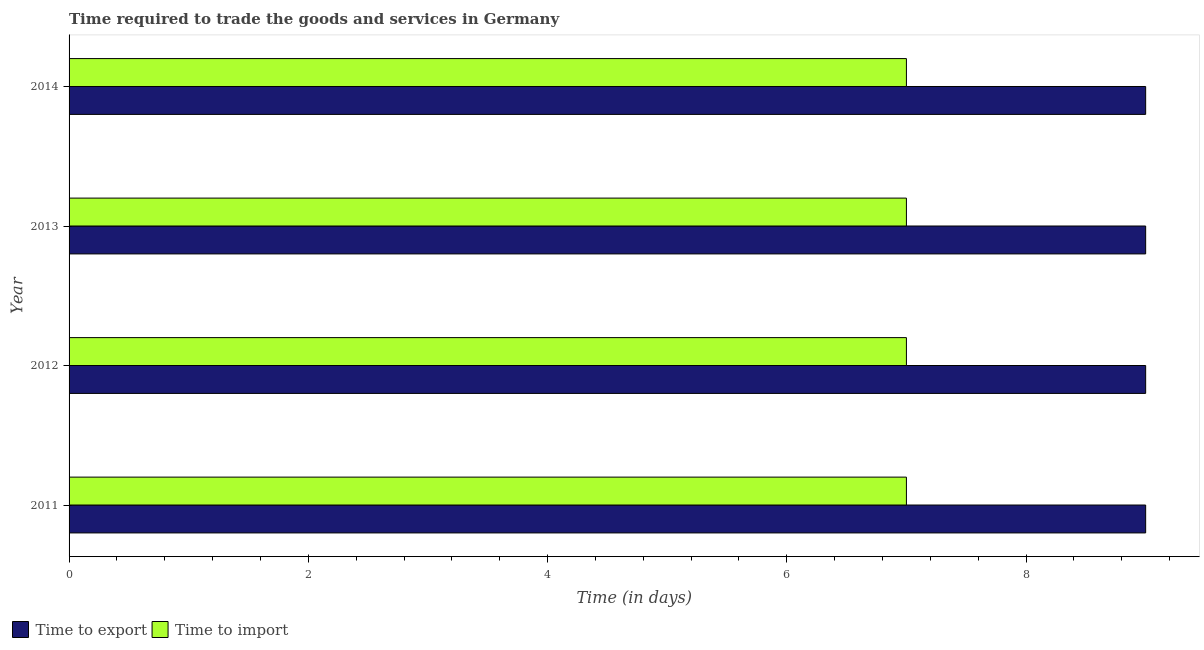How many different coloured bars are there?
Provide a short and direct response. 2. How many groups of bars are there?
Make the answer very short. 4. Are the number of bars on each tick of the Y-axis equal?
Offer a very short reply. Yes. How many bars are there on the 1st tick from the bottom?
Provide a short and direct response. 2. What is the label of the 3rd group of bars from the top?
Ensure brevity in your answer.  2012. In how many cases, is the number of bars for a given year not equal to the number of legend labels?
Your answer should be compact. 0. What is the time to export in 2013?
Your answer should be compact. 9. Across all years, what is the maximum time to export?
Offer a terse response. 9. Across all years, what is the minimum time to export?
Provide a succinct answer. 9. What is the total time to export in the graph?
Provide a succinct answer. 36. What is the difference between the time to export in 2011 and that in 2012?
Give a very brief answer. 0. What is the difference between the time to import in 2013 and the time to export in 2011?
Ensure brevity in your answer.  -2. What is the average time to export per year?
Provide a succinct answer. 9. In the year 2014, what is the difference between the time to export and time to import?
Ensure brevity in your answer.  2. Is the difference between the time to export in 2012 and 2013 greater than the difference between the time to import in 2012 and 2013?
Your answer should be compact. No. What is the difference between the highest and the second highest time to export?
Make the answer very short. 0. What is the difference between the highest and the lowest time to export?
Your answer should be compact. 0. In how many years, is the time to import greater than the average time to import taken over all years?
Offer a terse response. 0. Is the sum of the time to import in 2012 and 2014 greater than the maximum time to export across all years?
Ensure brevity in your answer.  Yes. What does the 1st bar from the top in 2013 represents?
Offer a very short reply. Time to import. What does the 1st bar from the bottom in 2011 represents?
Provide a succinct answer. Time to export. Are all the bars in the graph horizontal?
Provide a short and direct response. Yes. How many years are there in the graph?
Make the answer very short. 4. Are the values on the major ticks of X-axis written in scientific E-notation?
Provide a succinct answer. No. Does the graph contain any zero values?
Your answer should be compact. No. Does the graph contain grids?
Give a very brief answer. No. Where does the legend appear in the graph?
Your answer should be compact. Bottom left. How many legend labels are there?
Offer a terse response. 2. What is the title of the graph?
Your answer should be compact. Time required to trade the goods and services in Germany. What is the label or title of the X-axis?
Your answer should be compact. Time (in days). What is the label or title of the Y-axis?
Ensure brevity in your answer.  Year. What is the Time (in days) in Time to export in 2011?
Ensure brevity in your answer.  9. What is the Time (in days) of Time to import in 2011?
Provide a short and direct response. 7. What is the Time (in days) in Time to export in 2012?
Offer a very short reply. 9. What is the Time (in days) in Time to import in 2012?
Give a very brief answer. 7. What is the Time (in days) in Time to export in 2013?
Ensure brevity in your answer.  9. What is the Time (in days) in Time to import in 2013?
Give a very brief answer. 7. What is the Time (in days) of Time to import in 2014?
Your answer should be very brief. 7. Across all years, what is the maximum Time (in days) in Time to export?
Your response must be concise. 9. Across all years, what is the maximum Time (in days) of Time to import?
Provide a short and direct response. 7. What is the total Time (in days) of Time to import in the graph?
Ensure brevity in your answer.  28. What is the difference between the Time (in days) in Time to import in 2011 and that in 2012?
Give a very brief answer. 0. What is the difference between the Time (in days) of Time to export in 2011 and that in 2013?
Keep it short and to the point. 0. What is the difference between the Time (in days) of Time to export in 2011 and that in 2014?
Your answer should be compact. 0. What is the difference between the Time (in days) of Time to export in 2012 and that in 2013?
Offer a terse response. 0. What is the difference between the Time (in days) of Time to import in 2012 and that in 2013?
Offer a very short reply. 0. What is the difference between the Time (in days) of Time to export in 2012 and that in 2014?
Your response must be concise. 0. What is the difference between the Time (in days) of Time to import in 2012 and that in 2014?
Your answer should be compact. 0. What is the difference between the Time (in days) in Time to export in 2011 and the Time (in days) in Time to import in 2012?
Make the answer very short. 2. What is the difference between the Time (in days) of Time to export in 2012 and the Time (in days) of Time to import in 2013?
Give a very brief answer. 2. What is the difference between the Time (in days) in Time to export in 2012 and the Time (in days) in Time to import in 2014?
Keep it short and to the point. 2. What is the difference between the Time (in days) in Time to export in 2013 and the Time (in days) in Time to import in 2014?
Your response must be concise. 2. What is the average Time (in days) in Time to export per year?
Keep it short and to the point. 9. In the year 2013, what is the difference between the Time (in days) of Time to export and Time (in days) of Time to import?
Make the answer very short. 2. What is the ratio of the Time (in days) of Time to import in 2011 to that in 2012?
Give a very brief answer. 1. What is the ratio of the Time (in days) in Time to import in 2011 to that in 2013?
Your answer should be compact. 1. What is the ratio of the Time (in days) of Time to import in 2011 to that in 2014?
Give a very brief answer. 1. What is the ratio of the Time (in days) in Time to import in 2012 to that in 2014?
Provide a short and direct response. 1. What is the ratio of the Time (in days) of Time to export in 2013 to that in 2014?
Ensure brevity in your answer.  1. What is the difference between the highest and the second highest Time (in days) in Time to export?
Your answer should be compact. 0. What is the difference between the highest and the second highest Time (in days) of Time to import?
Your answer should be compact. 0. 